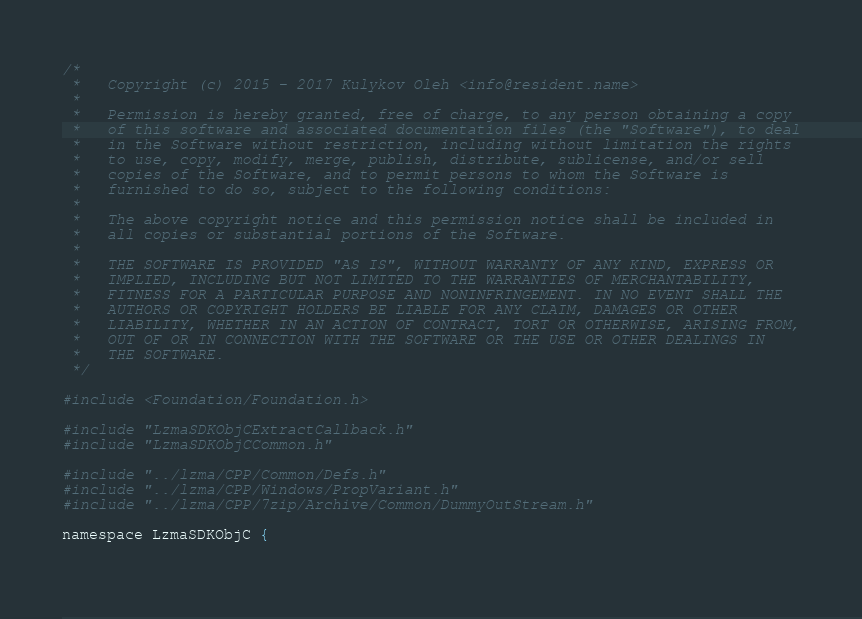<code> <loc_0><loc_0><loc_500><loc_500><_ObjectiveC_>/*
 *   Copyright (c) 2015 - 2017 Kulykov Oleh <info@resident.name>
 *
 *   Permission is hereby granted, free of charge, to any person obtaining a copy
 *   of this software and associated documentation files (the "Software"), to deal
 *   in the Software without restriction, including without limitation the rights
 *   to use, copy, modify, merge, publish, distribute, sublicense, and/or sell
 *   copies of the Software, and to permit persons to whom the Software is
 *   furnished to do so, subject to the following conditions:
 *
 *   The above copyright notice and this permission notice shall be included in
 *   all copies or substantial portions of the Software.
 *
 *   THE SOFTWARE IS PROVIDED "AS IS", WITHOUT WARRANTY OF ANY KIND, EXPRESS OR
 *   IMPLIED, INCLUDING BUT NOT LIMITED TO THE WARRANTIES OF MERCHANTABILITY,
 *   FITNESS FOR A PARTICULAR PURPOSE AND NONINFRINGEMENT. IN NO EVENT SHALL THE
 *   AUTHORS OR COPYRIGHT HOLDERS BE LIABLE FOR ANY CLAIM, DAMAGES OR OTHER
 *   LIABILITY, WHETHER IN AN ACTION OF CONTRACT, TORT OR OTHERWISE, ARISING FROM,
 *   OUT OF OR IN CONNECTION WITH THE SOFTWARE OR THE USE OR OTHER DEALINGS IN
 *   THE SOFTWARE.
 */

#include <Foundation/Foundation.h>

#include "LzmaSDKObjCExtractCallback.h"
#include "LzmaSDKObjCCommon.h"

#include "../lzma/CPP/Common/Defs.h"
#include "../lzma/CPP/Windows/PropVariant.h"
#include "../lzma/CPP/7zip/Archive/Common/DummyOutStream.h"

namespace LzmaSDKObjC {
	</code> 